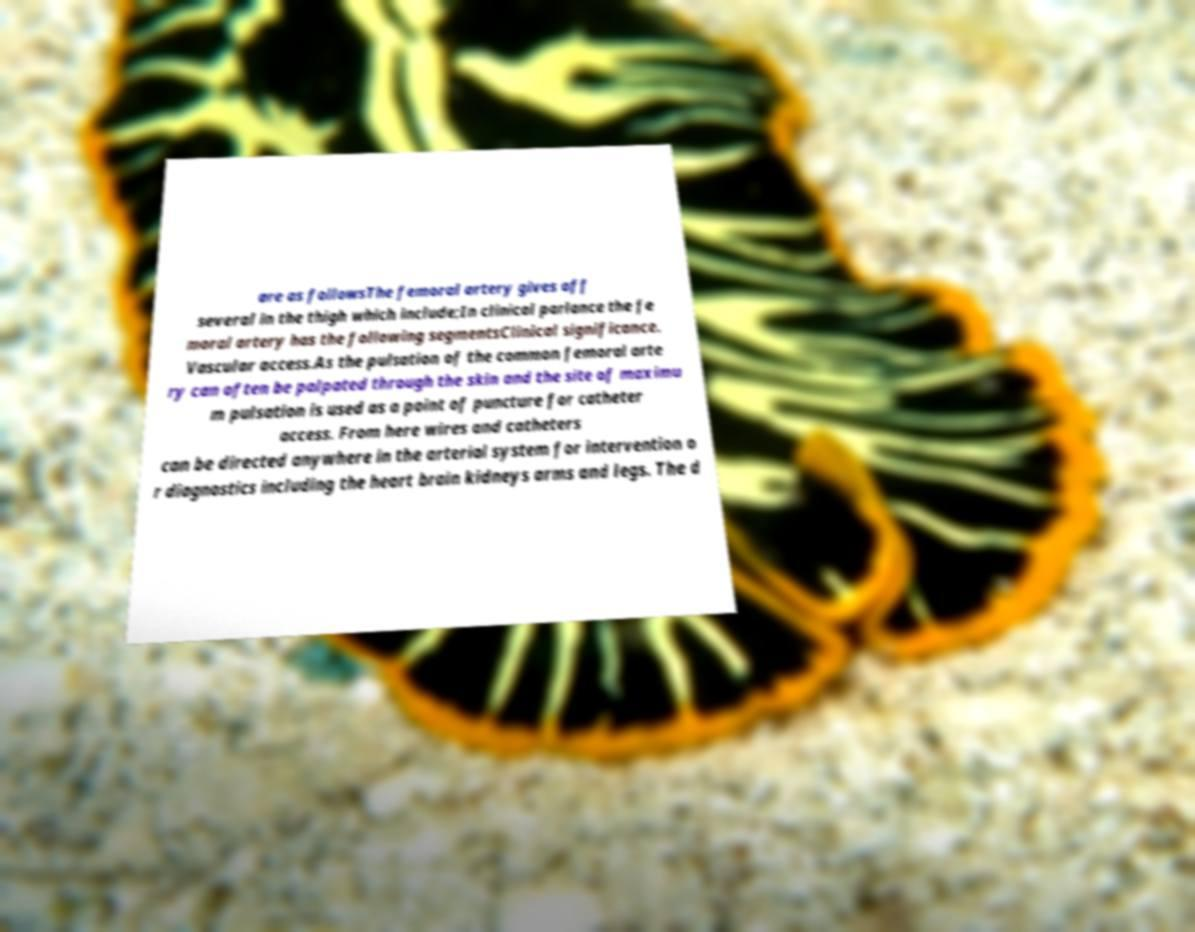There's text embedded in this image that I need extracted. Can you transcribe it verbatim? are as followsThe femoral artery gives off several in the thigh which include;In clinical parlance the fe moral artery has the following segmentsClinical significance. Vascular access.As the pulsation of the common femoral arte ry can often be palpated through the skin and the site of maximu m pulsation is used as a point of puncture for catheter access. From here wires and catheters can be directed anywhere in the arterial system for intervention o r diagnostics including the heart brain kidneys arms and legs. The d 